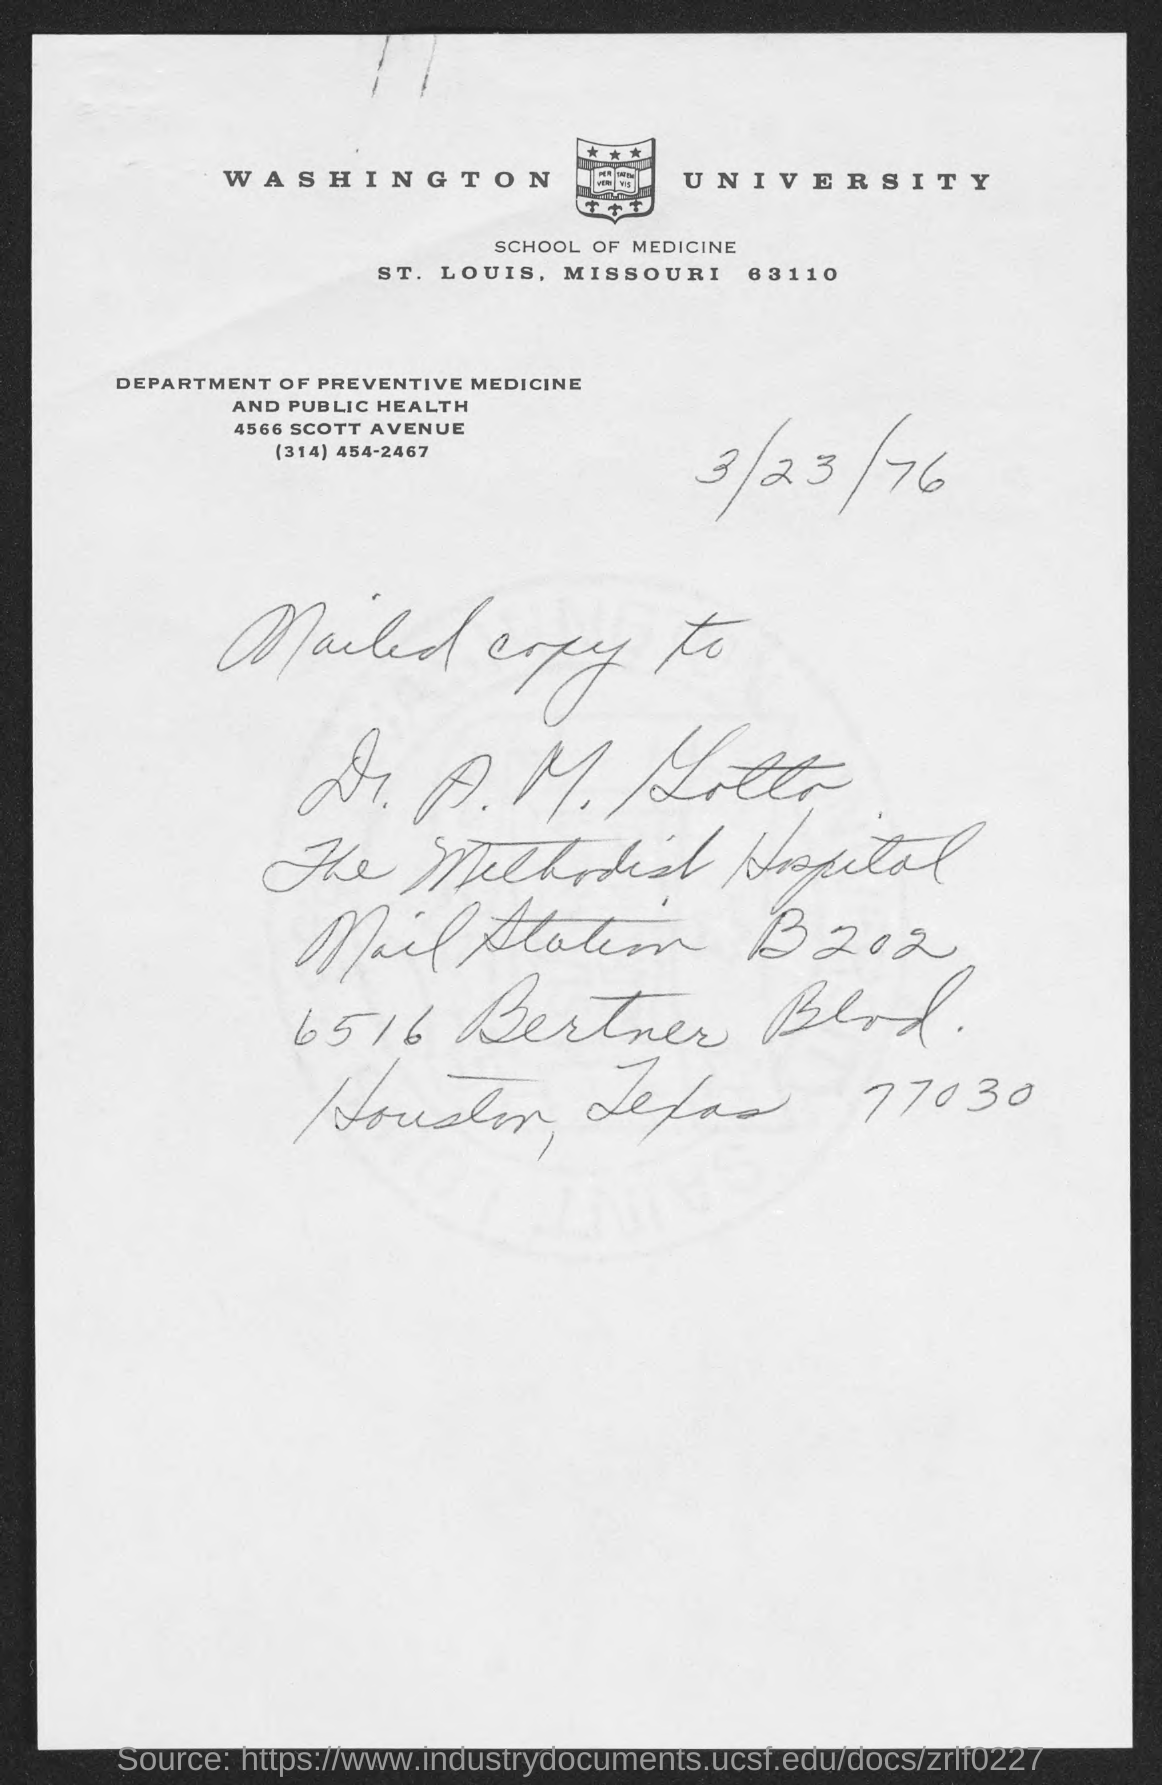Draw attention to some important aspects in this diagram. The university mentioned at the top of the page is Washington University. The contact information for the Department of Preventive Medicine and Public Health is (314) 454-2467. 